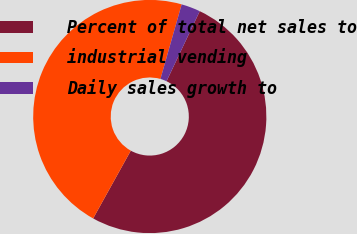Convert chart to OTSL. <chart><loc_0><loc_0><loc_500><loc_500><pie_chart><fcel>Percent of total net sales to<fcel>industrial vending<fcel>Daily sales growth to<nl><fcel>51.02%<fcel>46.34%<fcel>2.64%<nl></chart> 